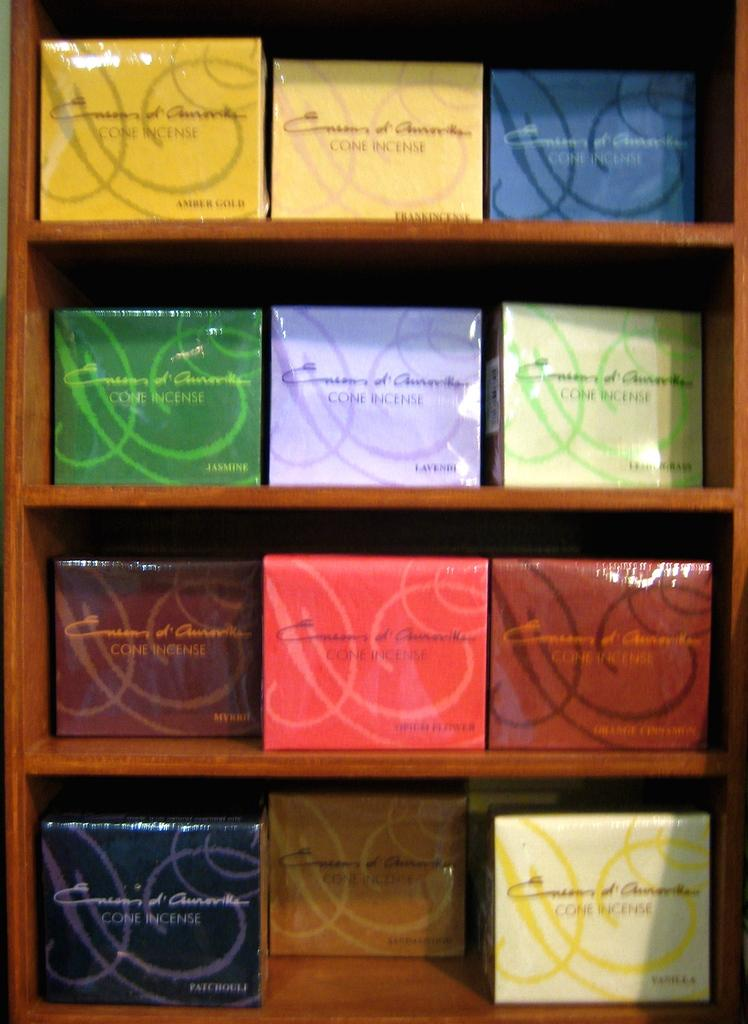What is the main structure visible in the image? There is a rack in the image. What is placed on the rack? There are boxes on the rack. Can you describe the appearance of the boxes? The boxes have different colors. What type of band is playing music in the image? There is no band present in the image; it only features a rack with boxes of different colors. 